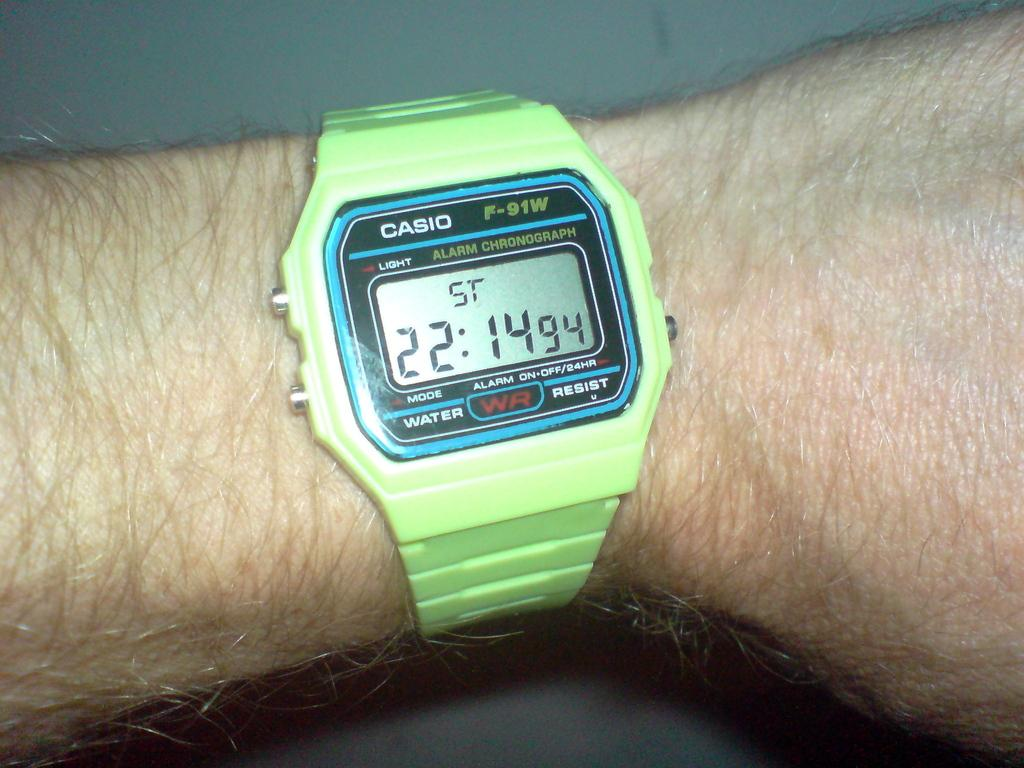<image>
Render a clear and concise summary of the photo. Man is wearing a green casio watch with a timer on it 